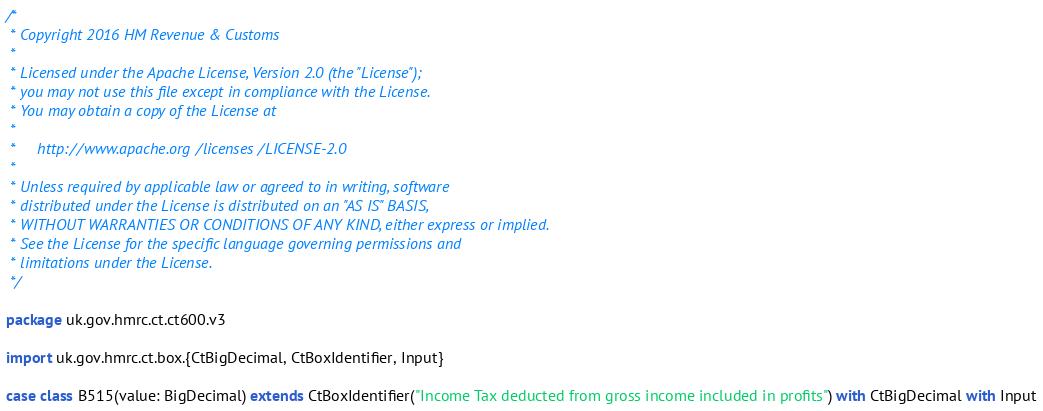Convert code to text. <code><loc_0><loc_0><loc_500><loc_500><_Scala_>/*
 * Copyright 2016 HM Revenue & Customs
 *
 * Licensed under the Apache License, Version 2.0 (the "License");
 * you may not use this file except in compliance with the License.
 * You may obtain a copy of the License at
 *
 *     http://www.apache.org/licenses/LICENSE-2.0
 *
 * Unless required by applicable law or agreed to in writing, software
 * distributed under the License is distributed on an "AS IS" BASIS,
 * WITHOUT WARRANTIES OR CONDITIONS OF ANY KIND, either express or implied.
 * See the License for the specific language governing permissions and
 * limitations under the License.
 */

package uk.gov.hmrc.ct.ct600.v3

import uk.gov.hmrc.ct.box.{CtBigDecimal, CtBoxIdentifier, Input}

case class B515(value: BigDecimal) extends CtBoxIdentifier("Income Tax deducted from gross income included in profits") with CtBigDecimal with Input
</code> 